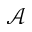Convert formula to latex. <formula><loc_0><loc_0><loc_500><loc_500>\mathcal { A }</formula> 